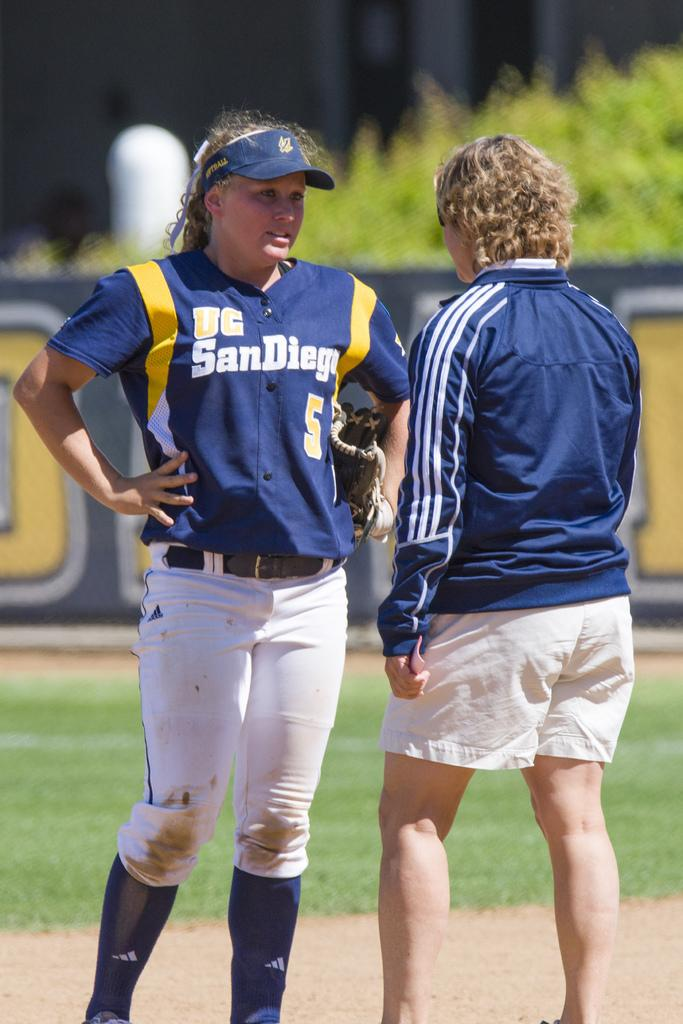How many people are in the image? There are two people standing on the ground in the image. What is the woman wearing? The woman is wearing a cap and gloves. What can be seen in the background of the image? There is grass, plants, a board, and some unspecified objects. What letters are being spelled out by the team in the image? There is no team present in the image, and no letters are being spelled out. Additionally, there is no mention of a spade in the image. 